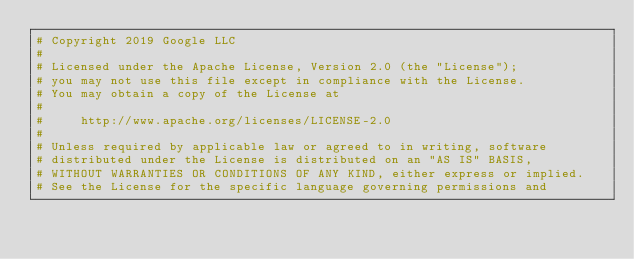Convert code to text. <code><loc_0><loc_0><loc_500><loc_500><_Elixir_># Copyright 2019 Google LLC
#
# Licensed under the Apache License, Version 2.0 (the "License");
# you may not use this file except in compliance with the License.
# You may obtain a copy of the License at
#
#     http://www.apache.org/licenses/LICENSE-2.0
#
# Unless required by applicable law or agreed to in writing, software
# distributed under the License is distributed on an "AS IS" BASIS,
# WITHOUT WARRANTIES OR CONDITIONS OF ANY KIND, either express or implied.
# See the License for the specific language governing permissions and</code> 